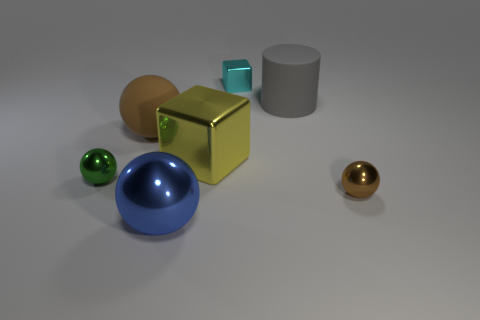What is the shape of the large thing that is both in front of the large rubber sphere and behind the small green metallic ball?
Give a very brief answer. Cube. How many other things are the same shape as the large brown matte object?
Offer a terse response. 3. What is the size of the yellow shiny thing?
Make the answer very short. Large. How many objects are brown things or small purple shiny cylinders?
Your answer should be very brief. 2. There is a brown sphere that is to the right of the large matte ball; how big is it?
Ensure brevity in your answer.  Small. Are there any other things that have the same size as the yellow metal block?
Offer a very short reply. Yes. There is a tiny object that is both in front of the big matte cylinder and left of the gray rubber thing; what is its color?
Give a very brief answer. Green. Do the big ball in front of the big metallic cube and the small cyan thing have the same material?
Your answer should be compact. Yes. Is the color of the big rubber cylinder the same as the small metal object that is to the right of the tiny cyan block?
Offer a very short reply. No. There is a small green object; are there any small balls to the left of it?
Make the answer very short. No. 